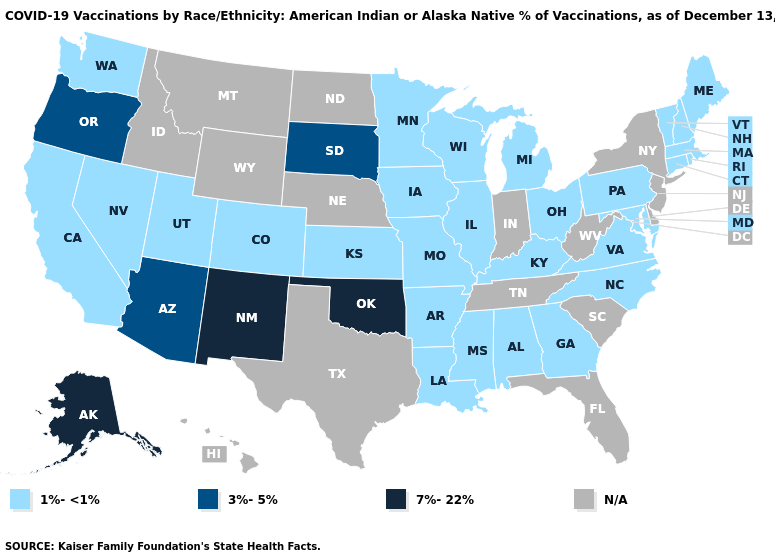What is the value of North Carolina?
Keep it brief. 1%-<1%. Name the states that have a value in the range 3%-5%?
Write a very short answer. Arizona, Oregon, South Dakota. Among the states that border Minnesota , does South Dakota have the highest value?
Short answer required. Yes. Name the states that have a value in the range 3%-5%?
Short answer required. Arizona, Oregon, South Dakota. What is the value of Louisiana?
Give a very brief answer. 1%-<1%. Name the states that have a value in the range 7%-22%?
Short answer required. Alaska, New Mexico, Oklahoma. Among the states that border New Hampshire , which have the highest value?
Short answer required. Maine, Massachusetts, Vermont. Name the states that have a value in the range 1%-<1%?
Be succinct. Alabama, Arkansas, California, Colorado, Connecticut, Georgia, Illinois, Iowa, Kansas, Kentucky, Louisiana, Maine, Maryland, Massachusetts, Michigan, Minnesota, Mississippi, Missouri, Nevada, New Hampshire, North Carolina, Ohio, Pennsylvania, Rhode Island, Utah, Vermont, Virginia, Washington, Wisconsin. What is the lowest value in the USA?
Write a very short answer. 1%-<1%. Among the states that border Michigan , which have the lowest value?
Give a very brief answer. Ohio, Wisconsin. Which states have the lowest value in the Northeast?
Quick response, please. Connecticut, Maine, Massachusetts, New Hampshire, Pennsylvania, Rhode Island, Vermont. Does the map have missing data?
Keep it brief. Yes. What is the highest value in the West ?
Short answer required. 7%-22%. Is the legend a continuous bar?
Quick response, please. No. What is the highest value in states that border Kansas?
Be succinct. 7%-22%. 